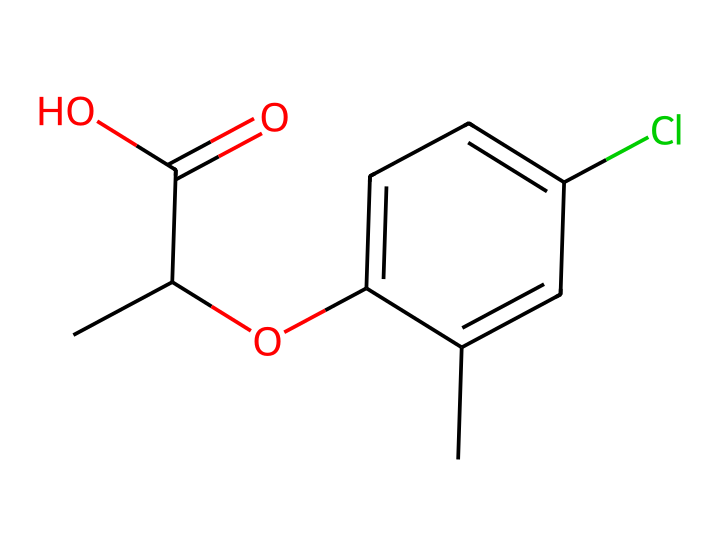What is the total number of carbon atoms in the chemical composition of mecoprop? To determine the total number of carbon atoms, we can analyze the SMILES representation. The structure includes three carbon atoms in the chain (CC(C(=O)O)), plus three additional carbons from the aromatic ring (c1ccc(cc1)), totaling six.
Answer: six How many oxygen atoms are present in mecoprop? In the SMILES structure, we see one carbonyl (C(=O)) and one hydroxyl (O) group, for a total of two oxygen atoms.
Answer: two What functional group is represented by the 'C(=O)O' part of the chemical? The 'C(=O)O' indicates the presence of a carboxylic acid functional group, characterized by a carbon atom doubly bonded to an oxygen atom and singly bonded to a hydroxyl group.
Answer: carboxylic acid Which element is represented by the 'Cl' in the structure? The 'Cl' indicates the presence of chlorine, which is a halogen atom in this herbicide's structure.
Answer: chlorine What type of compound is mecoprop categorized as? Considering the function and chemical behavior implied by the structure, mecoprop is categorized as a herbicide, specifically a phenoxy herbicide, due to the presence of the aromatic phenolic structure and functional groups.
Answer: phenoxy herbicide How does the presence of chlorine in mecoprop affect its herbicidal properties? The presence of chlorine often enhances the herbicidal activity of compounds by increasing their lipophilicity, allowing for better absorption by plants, which facilitates their action as herbicides.
Answer: enhances activity 